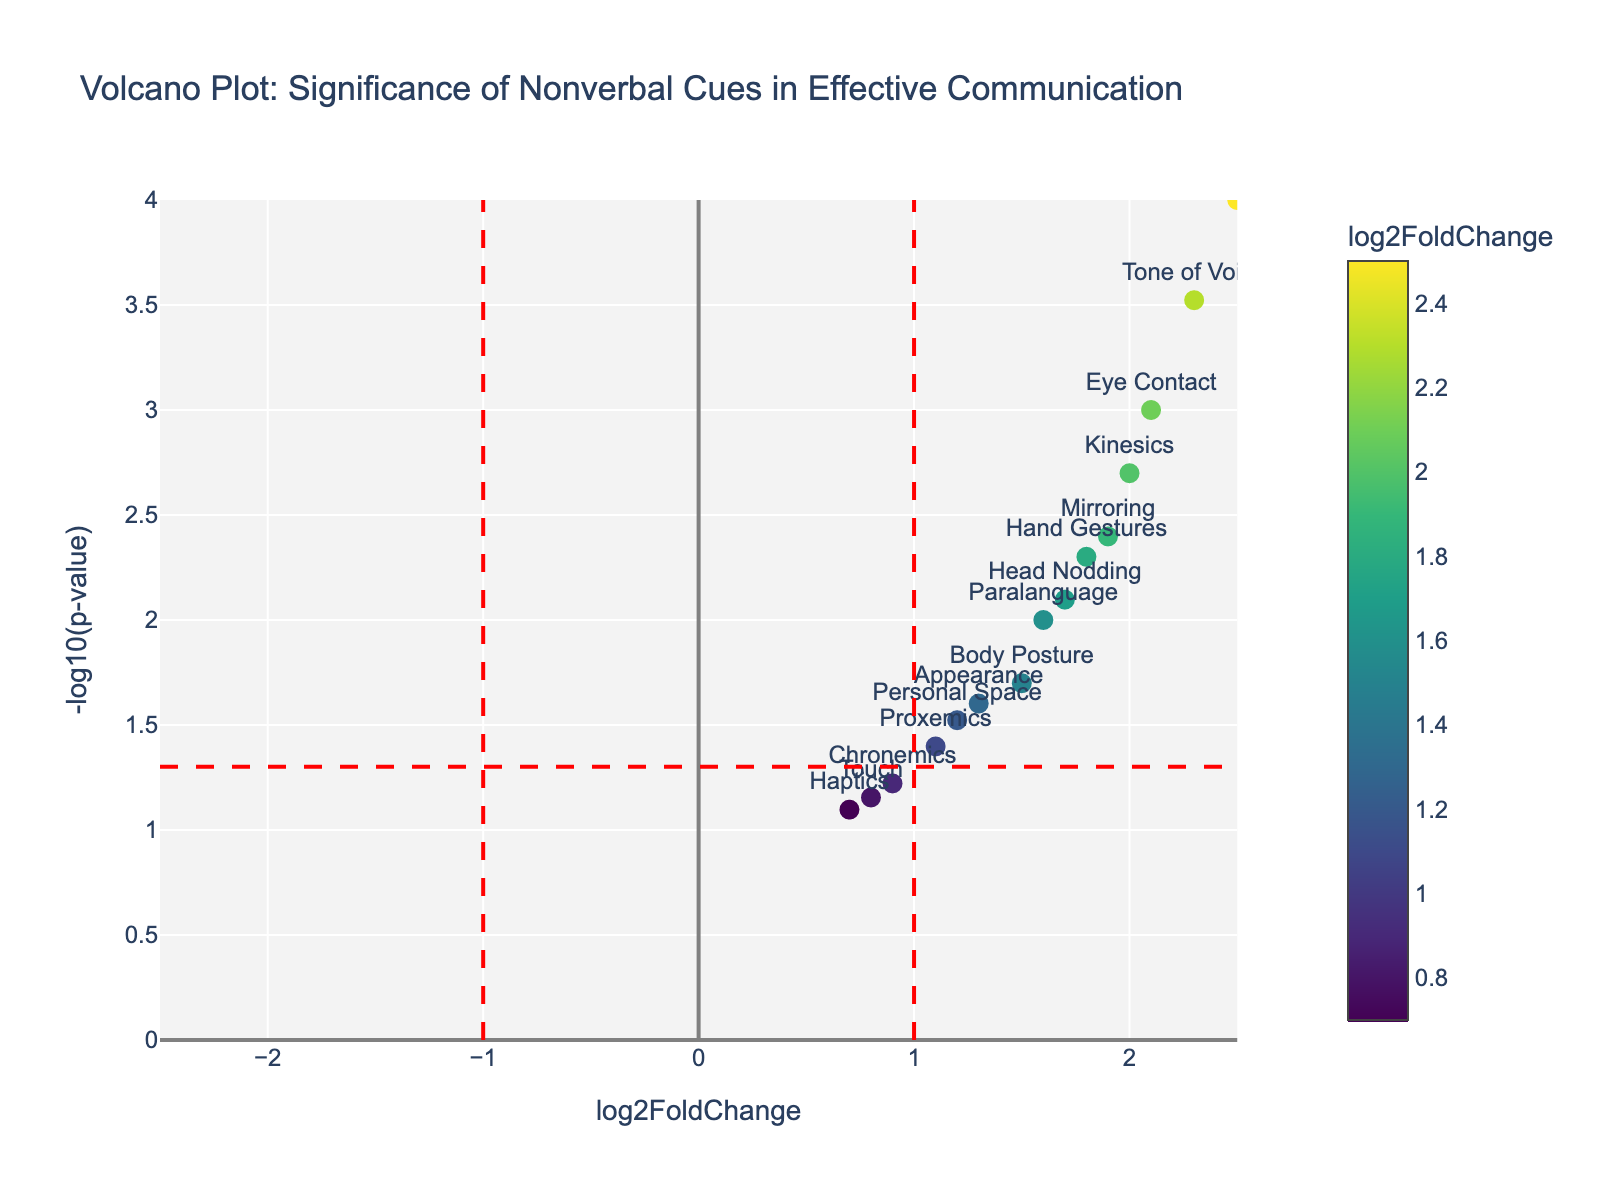How many nonverbal cues have a log2FoldChange greater than 1? To answer this, identify the points on the x-axis (log2FoldChange) that are greater than 1. Count these points. The data points with log2FoldChange greater than 1 are Eye Contact, Hand Gestures, Facial Expressions, Tone of Voice, Head Nodding, Mirroring, and Kinesics, which results in 7 points.
Answer: 7 Which nonverbal cue has the smallest p-value? The smallest p-value corresponds to the highest value on the y-axis (-log10(p-value)). Identify the highest point on the y-axis and check the corresponding label. The highest point corresponds to Facial Expressions.
Answer: Facial Expressions What is the log2FoldChange and p-value for Tone of Voice? Locate the data point labeled "Tone of Voice" on the plot and read the corresponding values from the axes or the hover text. The log2FoldChange is about 2.3, and the p-value is 0.0003.
Answer: 2.3, 0.0003 Which nonverbal cue is closest to the threshold of significance (p-value = 0.05)? The threshold is represented by the horizontal red dashed line. Identify the point closest to this line and check the label. The point closest to the threshold is Personal Space.
Answer: Personal Space How many nonverbal cues have a p-value less than 0.01 and log2FoldChange greater than 1.5? Identify points above the red dashed line (-log10(0.01) = 2) and to the right of 1.5 on the x-axis. The points that meet these criteria are Eye Contact, Hand Gestures, Facial Expressions, Tone of Voice, Mirroring, and Kinesics (6 points).
Answer: 6 Which nonverbal cue has a log2FoldChange of approximately 1? Locate the data point with an x-value (log2FoldChange) around 1 and identify the corresponding label. The point with log2FoldChange around 1 is Proxemics.
Answer: Proxemics Is there any nonverbal cue with a negative log2FoldChange? Look for any data points on the left side of the y-axis (negative x-values). The plot does not show any nonverbal cues with negative log2FoldChange as all points are on the right side of the y-axis.
Answer: No Which nonverbal cue has the highest log2FoldChange? Identify the point farthest to the right on the x-axis (log2FoldChange) and check the label. The farthest right point corresponds to Facial Expressions.
Answer: Facial Expressions How many nonverbal cues have a log2FoldChange between 1.5 and 2.0? Count the data points whose x-values fall between 1.5 and 2.0. The points that meet this criterion are Body Posture, Head Nodding, and Paralanguage (3 points).
Answer: 3 